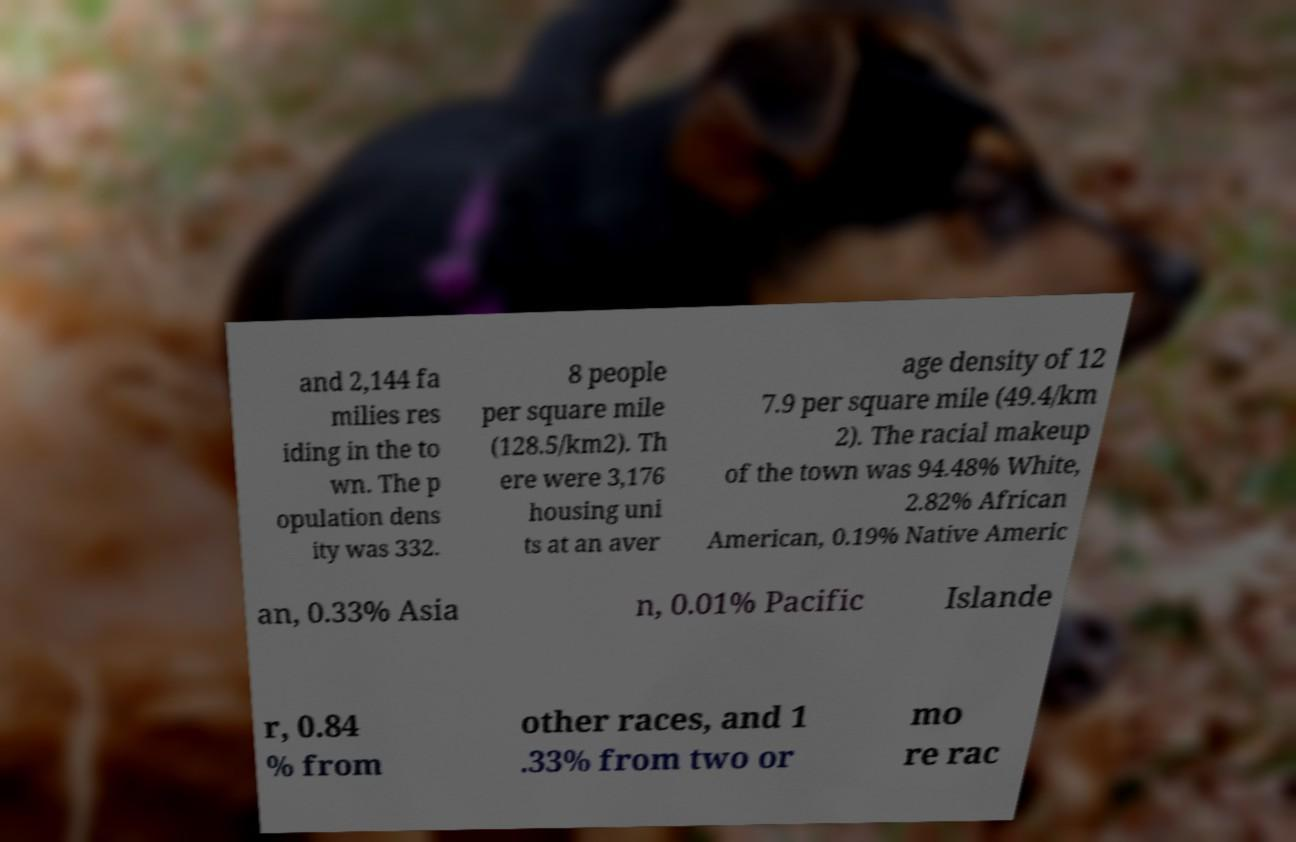I need the written content from this picture converted into text. Can you do that? and 2,144 fa milies res iding in the to wn. The p opulation dens ity was 332. 8 people per square mile (128.5/km2). Th ere were 3,176 housing uni ts at an aver age density of 12 7.9 per square mile (49.4/km 2). The racial makeup of the town was 94.48% White, 2.82% African American, 0.19% Native Americ an, 0.33% Asia n, 0.01% Pacific Islande r, 0.84 % from other races, and 1 .33% from two or mo re rac 